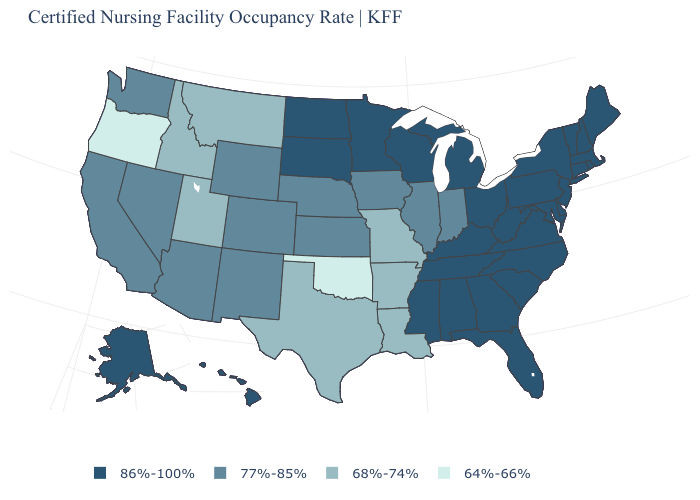What is the lowest value in states that border Virginia?
Be succinct. 86%-100%. How many symbols are there in the legend?
Give a very brief answer. 4. What is the lowest value in states that border New Jersey?
Be succinct. 86%-100%. Is the legend a continuous bar?
Give a very brief answer. No. What is the highest value in the West ?
Quick response, please. 86%-100%. What is the highest value in the MidWest ?
Keep it brief. 86%-100%. What is the highest value in states that border Massachusetts?
Keep it brief. 86%-100%. Is the legend a continuous bar?
Concise answer only. No. What is the value of Connecticut?
Short answer required. 86%-100%. Name the states that have a value in the range 64%-66%?
Be succinct. Oklahoma, Oregon. What is the value of New Mexico?
Give a very brief answer. 77%-85%. Among the states that border Montana , which have the highest value?
Short answer required. North Dakota, South Dakota. Does Tennessee have a lower value than Oregon?
Quick response, please. No. What is the value of Virginia?
Write a very short answer. 86%-100%. 